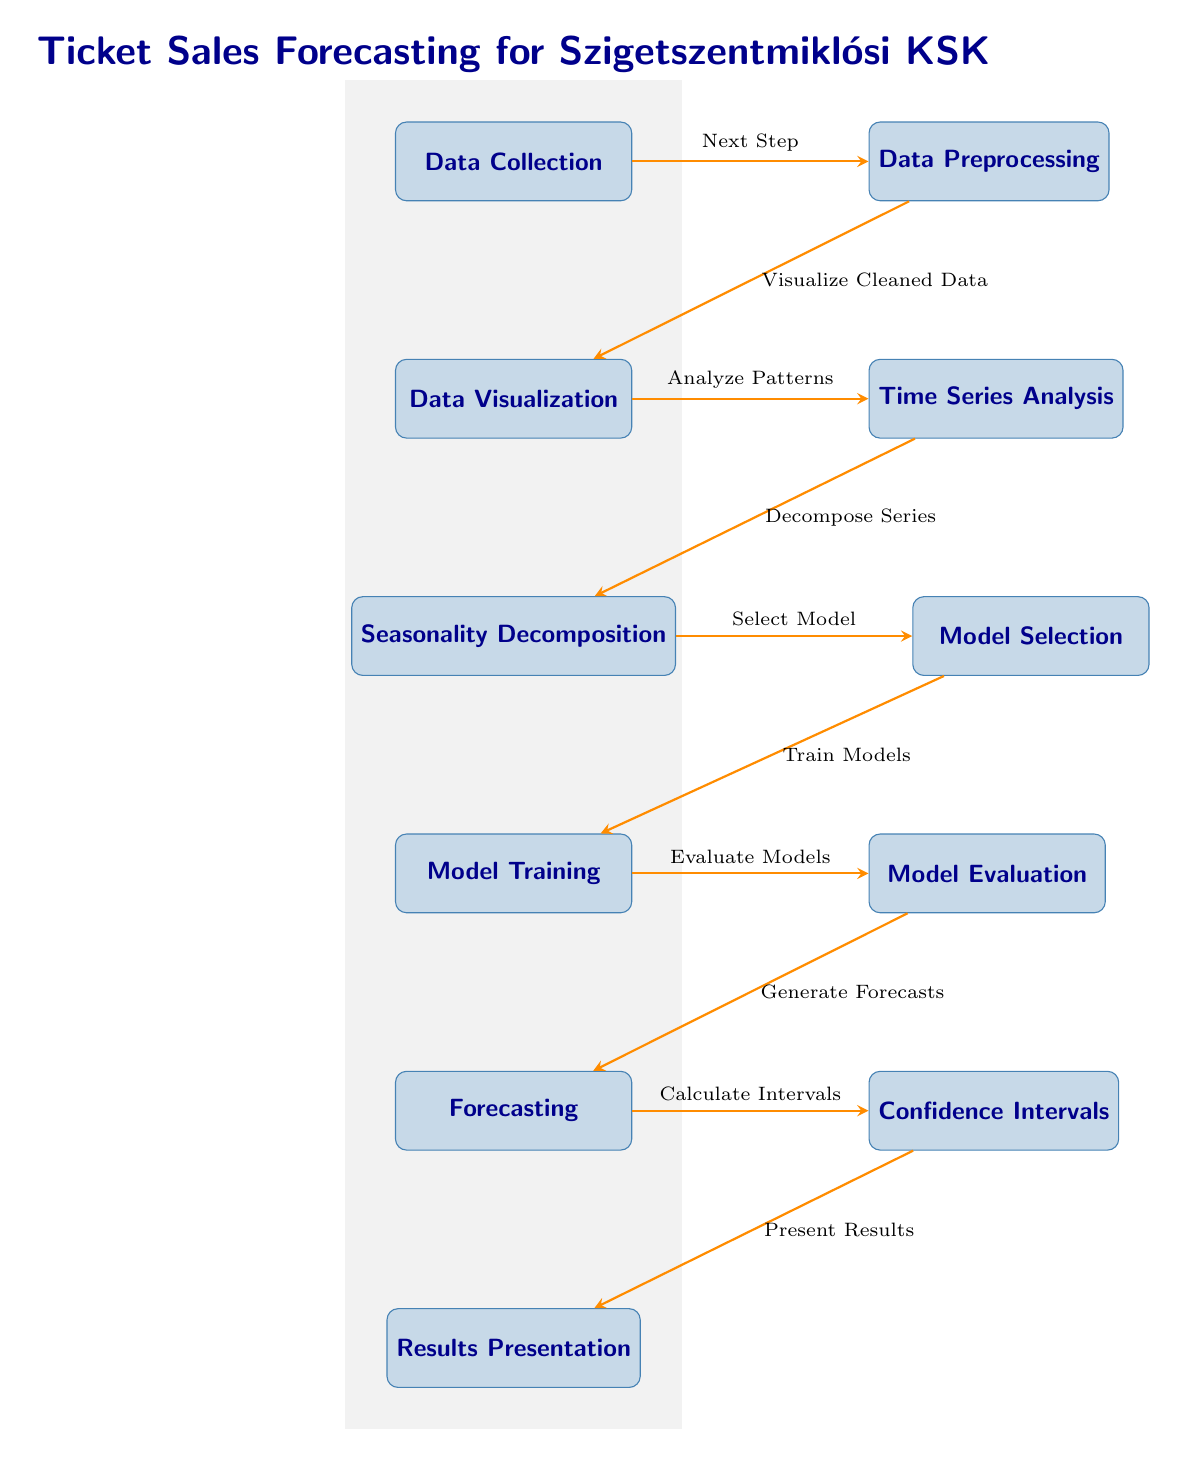What is the first step in the diagram? The first step in the diagram is represented by the node labeled "Data Collection." It is the initial stage of the ticket sales forecasting process.
Answer: Data Collection How many main processes are defined in the diagram? By counting the number of distinct process nodes in the diagram, we identify a total of 10 main processes.
Answer: 10 What comes after "Data Visualization"? Following "Data Visualization," the next step as indicated in the diagram is "Time Series Analysis." This denotes a flow in the process of forecasting.
Answer: Time Series Analysis Which step involves calculating prediction intervals? The step that involves calculating prediction intervals is labeled "Confidence Intervals." It follows the forecasting step.
Answer: Confidence Intervals Which two processes are located immediately below "Model Training"? Immediately below "Model Training," the processes are "Forecasting" and "Results Presentation." This indicates the subsequent actions taken after training the model.
Answer: Forecasting and Results Presentation What is the relationship between "Seasonality Decomposition" and "Model Selection"? The relationship is that "Seasonality Decomposition" precedes "Model Selection," indicating that after decomposing seasonal patterns, the appropriate model is chosen for forecasting.
Answer: Precedes How is the output presented after generating forecasts? The output is presented following the calculation of confidence intervals in the "Results Presentation" node, which is the final step in the diagram.
Answer: Results Presentation Which process involves cleaning the data? The process that focuses on cleaning the data is labeled "Data Preprocessing." This step is essential for ensuring quality data is used in the analysis.
Answer: Data Preprocessing What does "Data Visualization" analyze? "Data Visualization" analyzes patterns in the cleaned data, helping to gain insights before proceeding to time series analysis.
Answer: Patterns 